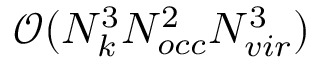<formula> <loc_0><loc_0><loc_500><loc_500>\mathcal { O } ( N _ { k } ^ { 3 } N _ { o c c } ^ { 2 } N _ { v i r } ^ { 3 } )</formula> 